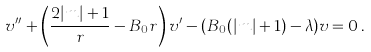<formula> <loc_0><loc_0><loc_500><loc_500>v ^ { \prime \prime } + \left ( \frac { 2 | m | + 1 } { r } - B _ { 0 } r \right ) v ^ { \prime } - ( B _ { 0 } ( | m | + 1 ) - \lambda ) v = 0 \, .</formula> 